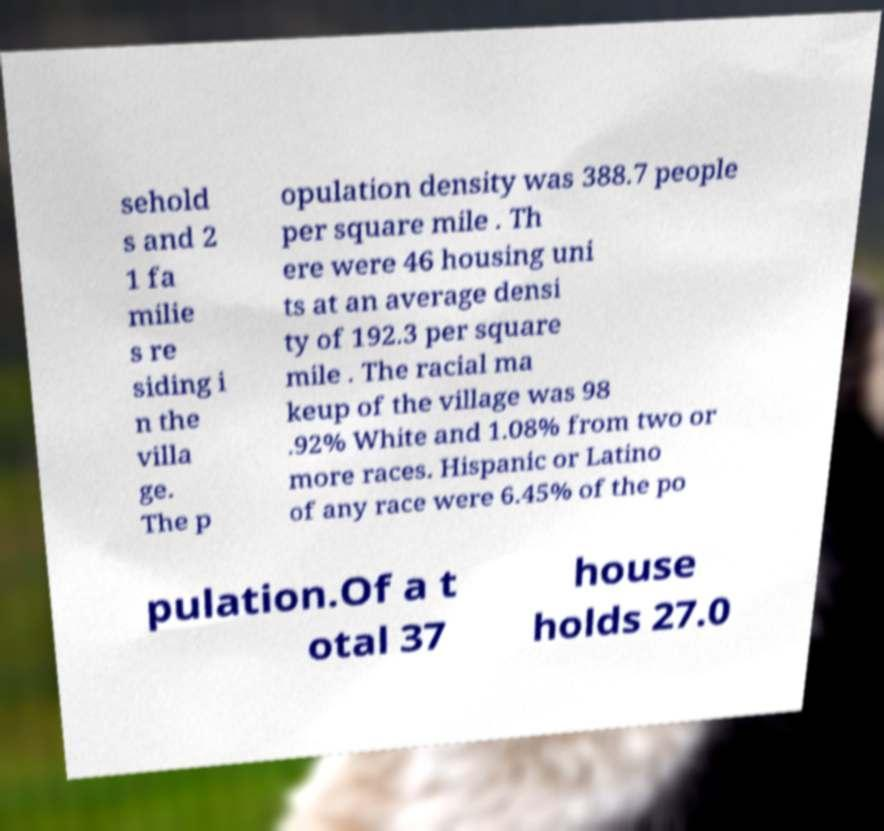Can you read and provide the text displayed in the image?This photo seems to have some interesting text. Can you extract and type it out for me? sehold s and 2 1 fa milie s re siding i n the villa ge. The p opulation density was 388.7 people per square mile . Th ere were 46 housing uni ts at an average densi ty of 192.3 per square mile . The racial ma keup of the village was 98 .92% White and 1.08% from two or more races. Hispanic or Latino of any race were 6.45% of the po pulation.Of a t otal 37 house holds 27.0 